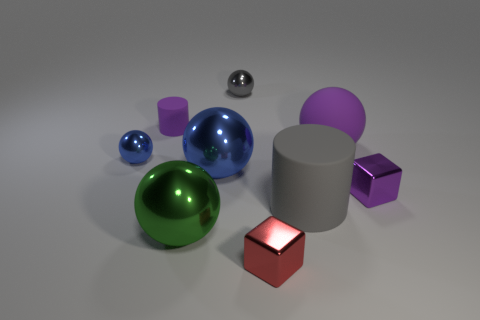Subtract all blue spheres. How many spheres are left? 3 Subtract all red cubes. How many blue spheres are left? 2 Add 1 large green things. How many objects exist? 10 Subtract all blue spheres. How many spheres are left? 3 Subtract all blocks. How many objects are left? 7 Subtract all yellow balls. Subtract all blue cubes. How many balls are left? 5 Add 5 green metallic things. How many green metallic things exist? 6 Subtract 0 green blocks. How many objects are left? 9 Subtract all large things. Subtract all small gray things. How many objects are left? 4 Add 3 tiny rubber cylinders. How many tiny rubber cylinders are left? 4 